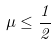<formula> <loc_0><loc_0><loc_500><loc_500>\mu \leq \frac { 1 } { 2 }</formula> 